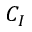Convert formula to latex. <formula><loc_0><loc_0><loc_500><loc_500>C _ { I }</formula> 